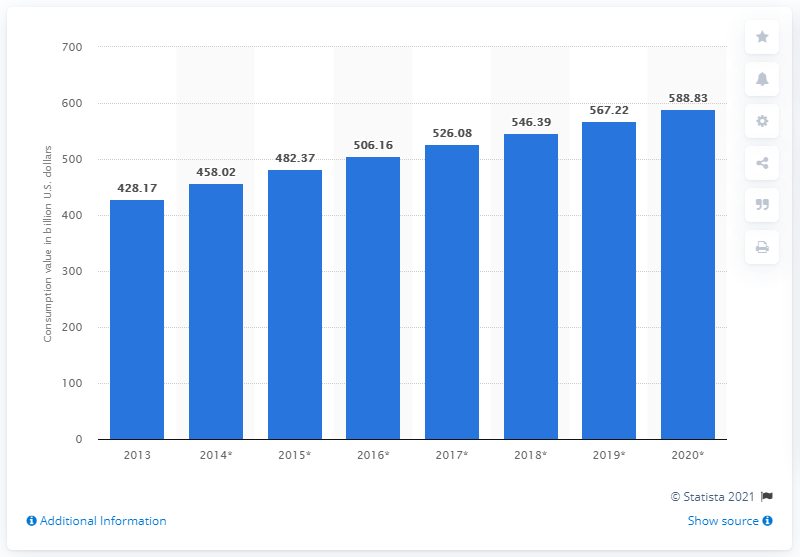Indicate a few pertinent items in this graphic. In 2013, the global consumption of household appliances was 428.17 million units. 